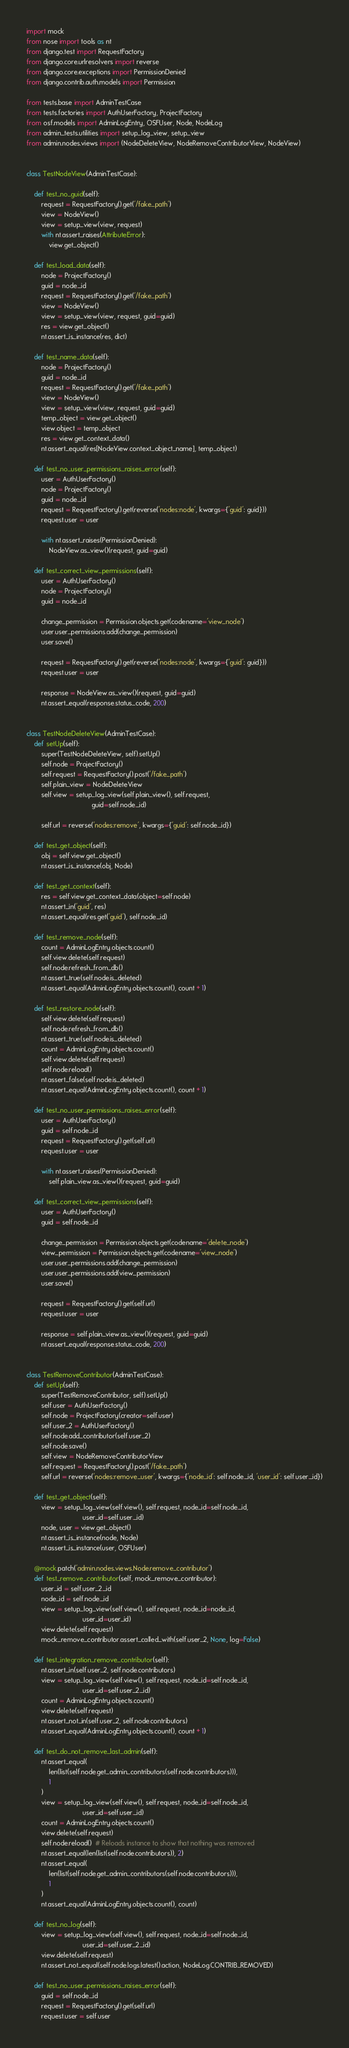<code> <loc_0><loc_0><loc_500><loc_500><_Python_>import mock
from nose import tools as nt
from django.test import RequestFactory
from django.core.urlresolvers import reverse
from django.core.exceptions import PermissionDenied
from django.contrib.auth.models import Permission

from tests.base import AdminTestCase
from tests.factories import AuthUserFactory, ProjectFactory
from osf.models import AdminLogEntry, OSFUser, Node, NodeLog
from admin_tests.utilities import setup_log_view, setup_view
from admin.nodes.views import (NodeDeleteView, NodeRemoveContributorView, NodeView)


class TestNodeView(AdminTestCase):

    def test_no_guid(self):
        request = RequestFactory().get('/fake_path')
        view = NodeView()
        view = setup_view(view, request)
        with nt.assert_raises(AttributeError):
            view.get_object()

    def test_load_data(self):
        node = ProjectFactory()
        guid = node._id
        request = RequestFactory().get('/fake_path')
        view = NodeView()
        view = setup_view(view, request, guid=guid)
        res = view.get_object()
        nt.assert_is_instance(res, dict)

    def test_name_data(self):
        node = ProjectFactory()
        guid = node._id
        request = RequestFactory().get('/fake_path')
        view = NodeView()
        view = setup_view(view, request, guid=guid)
        temp_object = view.get_object()
        view.object = temp_object
        res = view.get_context_data()
        nt.assert_equal(res[NodeView.context_object_name], temp_object)

    def test_no_user_permissions_raises_error(self):
        user = AuthUserFactory()
        node = ProjectFactory()
        guid = node._id
        request = RequestFactory().get(reverse('nodes:node', kwargs={'guid': guid}))
        request.user = user

        with nt.assert_raises(PermissionDenied):
            NodeView.as_view()(request, guid=guid)

    def test_correct_view_permissions(self):
        user = AuthUserFactory()
        node = ProjectFactory()
        guid = node._id

        change_permission = Permission.objects.get(codename='view_node')
        user.user_permissions.add(change_permission)
        user.save()

        request = RequestFactory().get(reverse('nodes:node', kwargs={'guid': guid}))
        request.user = user

        response = NodeView.as_view()(request, guid=guid)
        nt.assert_equal(response.status_code, 200)


class TestNodeDeleteView(AdminTestCase):
    def setUp(self):
        super(TestNodeDeleteView, self).setUp()
        self.node = ProjectFactory()
        self.request = RequestFactory().post('/fake_path')
        self.plain_view = NodeDeleteView
        self.view = setup_log_view(self.plain_view(), self.request,
                                   guid=self.node._id)

        self.url = reverse('nodes:remove', kwargs={'guid': self.node._id})

    def test_get_object(self):
        obj = self.view.get_object()
        nt.assert_is_instance(obj, Node)

    def test_get_context(self):
        res = self.view.get_context_data(object=self.node)
        nt.assert_in('guid', res)
        nt.assert_equal(res.get('guid'), self.node._id)

    def test_remove_node(self):
        count = AdminLogEntry.objects.count()
        self.view.delete(self.request)
        self.node.refresh_from_db()
        nt.assert_true(self.node.is_deleted)
        nt.assert_equal(AdminLogEntry.objects.count(), count + 1)

    def test_restore_node(self):
        self.view.delete(self.request)
        self.node.refresh_from_db()
        nt.assert_true(self.node.is_deleted)
        count = AdminLogEntry.objects.count()
        self.view.delete(self.request)
        self.node.reload()
        nt.assert_false(self.node.is_deleted)
        nt.assert_equal(AdminLogEntry.objects.count(), count + 1)

    def test_no_user_permissions_raises_error(self):
        user = AuthUserFactory()
        guid = self.node._id
        request = RequestFactory().get(self.url)
        request.user = user

        with nt.assert_raises(PermissionDenied):
            self.plain_view.as_view()(request, guid=guid)

    def test_correct_view_permissions(self):
        user = AuthUserFactory()
        guid = self.node._id

        change_permission = Permission.objects.get(codename='delete_node')
        view_permission = Permission.objects.get(codename='view_node')
        user.user_permissions.add(change_permission)
        user.user_permissions.add(view_permission)
        user.save()

        request = RequestFactory().get(self.url)
        request.user = user

        response = self.plain_view.as_view()(request, guid=guid)
        nt.assert_equal(response.status_code, 200)


class TestRemoveContributor(AdminTestCase):
    def setUp(self):
        super(TestRemoveContributor, self).setUp()
        self.user = AuthUserFactory()
        self.node = ProjectFactory(creator=self.user)
        self.user_2 = AuthUserFactory()
        self.node.add_contributor(self.user_2)
        self.node.save()
        self.view = NodeRemoveContributorView
        self.request = RequestFactory().post('/fake_path')
        self.url = reverse('nodes:remove_user', kwargs={'node_id': self.node._id, 'user_id': self.user._id})

    def test_get_object(self):
        view = setup_log_view(self.view(), self.request, node_id=self.node._id,
                              user_id=self.user._id)
        node, user = view.get_object()
        nt.assert_is_instance(node, Node)
        nt.assert_is_instance(user, OSFUser)

    @mock.patch('admin.nodes.views.Node.remove_contributor')
    def test_remove_contributor(self, mock_remove_contributor):
        user_id = self.user_2._id
        node_id = self.node._id
        view = setup_log_view(self.view(), self.request, node_id=node_id,
                              user_id=user_id)
        view.delete(self.request)
        mock_remove_contributor.assert_called_with(self.user_2, None, log=False)

    def test_integration_remove_contributor(self):
        nt.assert_in(self.user_2, self.node.contributors)
        view = setup_log_view(self.view(), self.request, node_id=self.node._id,
                              user_id=self.user_2._id)
        count = AdminLogEntry.objects.count()
        view.delete(self.request)
        nt.assert_not_in(self.user_2, self.node.contributors)
        nt.assert_equal(AdminLogEntry.objects.count(), count + 1)

    def test_do_not_remove_last_admin(self):
        nt.assert_equal(
            len(list(self.node.get_admin_contributors(self.node.contributors))),
            1
        )
        view = setup_log_view(self.view(), self.request, node_id=self.node._id,
                              user_id=self.user._id)
        count = AdminLogEntry.objects.count()
        view.delete(self.request)
        self.node.reload()  # Reloads instance to show that nothing was removed
        nt.assert_equal(len(list(self.node.contributors)), 2)
        nt.assert_equal(
            len(list(self.node.get_admin_contributors(self.node.contributors))),
            1
        )
        nt.assert_equal(AdminLogEntry.objects.count(), count)

    def test_no_log(self):
        view = setup_log_view(self.view(), self.request, node_id=self.node._id,
                              user_id=self.user_2._id)
        view.delete(self.request)
        nt.assert_not_equal(self.node.logs.latest().action, NodeLog.CONTRIB_REMOVED)

    def test_no_user_permissions_raises_error(self):
        guid = self.node._id
        request = RequestFactory().get(self.url)
        request.user = self.user
</code> 